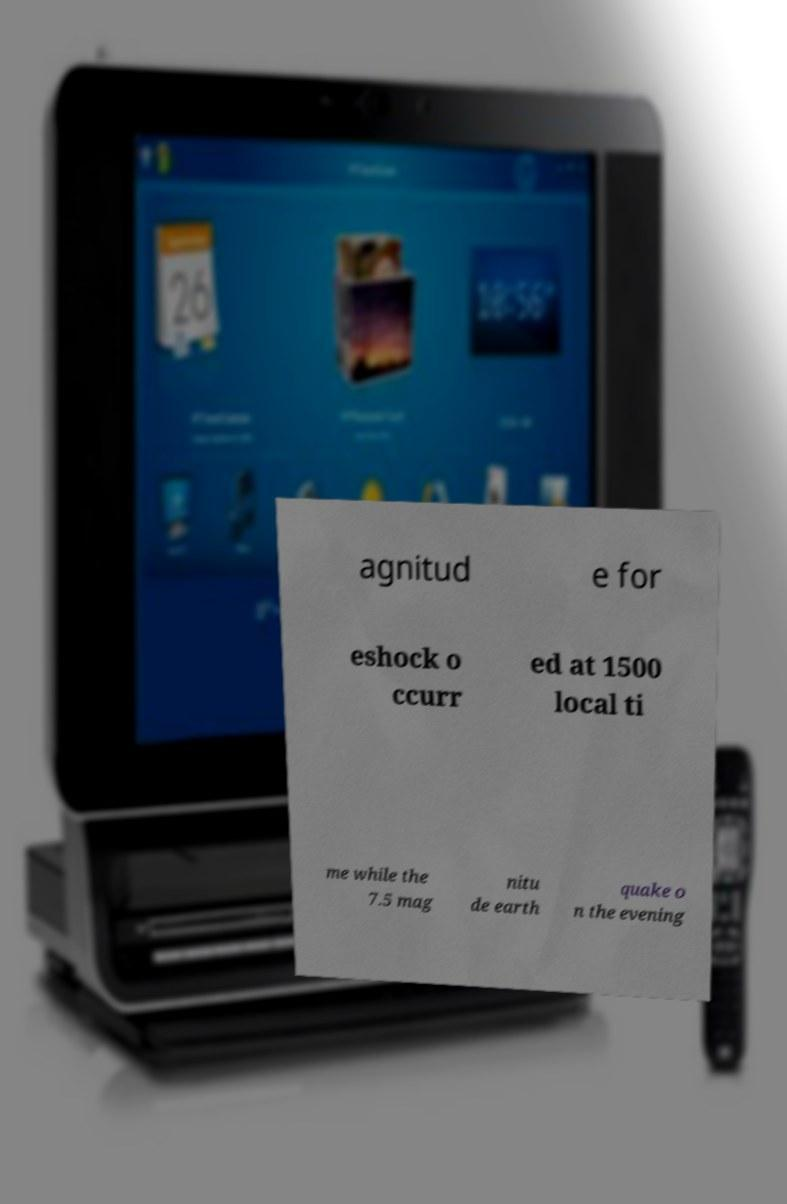For documentation purposes, I need the text within this image transcribed. Could you provide that? agnitud e for eshock o ccurr ed at 1500 local ti me while the 7.5 mag nitu de earth quake o n the evening 